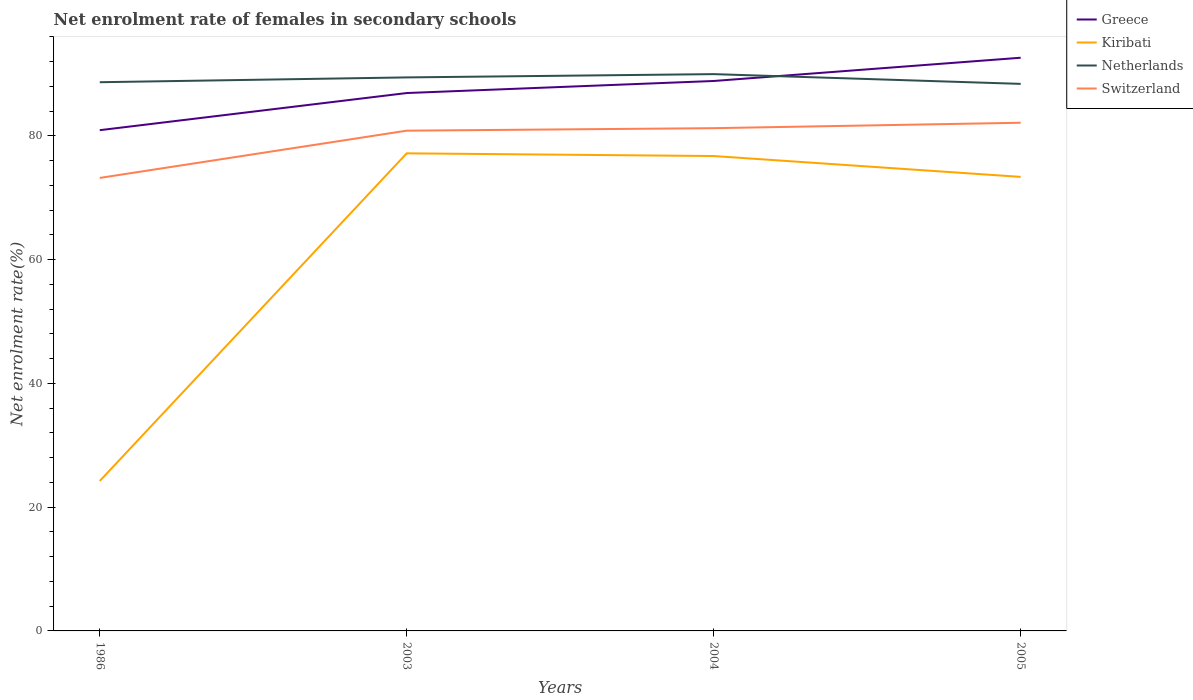How many different coloured lines are there?
Your answer should be compact. 4. Does the line corresponding to Switzerland intersect with the line corresponding to Kiribati?
Provide a short and direct response. No. Across all years, what is the maximum net enrolment rate of females in secondary schools in Greece?
Keep it short and to the point. 80.91. In which year was the net enrolment rate of females in secondary schools in Greece maximum?
Your response must be concise. 1986. What is the total net enrolment rate of females in secondary schools in Greece in the graph?
Give a very brief answer. -3.76. What is the difference between the highest and the second highest net enrolment rate of females in secondary schools in Greece?
Your answer should be very brief. 11.71. Is the net enrolment rate of females in secondary schools in Switzerland strictly greater than the net enrolment rate of females in secondary schools in Greece over the years?
Keep it short and to the point. Yes. How many lines are there?
Offer a terse response. 4. What is the difference between two consecutive major ticks on the Y-axis?
Your response must be concise. 20. Does the graph contain any zero values?
Ensure brevity in your answer.  No. Where does the legend appear in the graph?
Provide a short and direct response. Top right. How are the legend labels stacked?
Make the answer very short. Vertical. What is the title of the graph?
Provide a short and direct response. Net enrolment rate of females in secondary schools. What is the label or title of the X-axis?
Your answer should be compact. Years. What is the label or title of the Y-axis?
Give a very brief answer. Net enrolment rate(%). What is the Net enrolment rate(%) in Greece in 1986?
Your answer should be very brief. 80.91. What is the Net enrolment rate(%) in Kiribati in 1986?
Your response must be concise. 24.23. What is the Net enrolment rate(%) of Netherlands in 1986?
Your answer should be compact. 88.66. What is the Net enrolment rate(%) of Switzerland in 1986?
Ensure brevity in your answer.  73.2. What is the Net enrolment rate(%) in Greece in 2003?
Give a very brief answer. 86.91. What is the Net enrolment rate(%) in Kiribati in 2003?
Keep it short and to the point. 77.17. What is the Net enrolment rate(%) in Netherlands in 2003?
Your answer should be very brief. 89.44. What is the Net enrolment rate(%) of Switzerland in 2003?
Provide a short and direct response. 80.83. What is the Net enrolment rate(%) of Greece in 2004?
Your response must be concise. 88.86. What is the Net enrolment rate(%) of Kiribati in 2004?
Offer a terse response. 76.73. What is the Net enrolment rate(%) of Netherlands in 2004?
Your response must be concise. 89.97. What is the Net enrolment rate(%) in Switzerland in 2004?
Offer a terse response. 81.24. What is the Net enrolment rate(%) of Greece in 2005?
Give a very brief answer. 92.62. What is the Net enrolment rate(%) in Kiribati in 2005?
Your answer should be compact. 73.36. What is the Net enrolment rate(%) in Netherlands in 2005?
Your answer should be very brief. 88.39. What is the Net enrolment rate(%) in Switzerland in 2005?
Offer a terse response. 82.11. Across all years, what is the maximum Net enrolment rate(%) of Greece?
Provide a succinct answer. 92.62. Across all years, what is the maximum Net enrolment rate(%) in Kiribati?
Ensure brevity in your answer.  77.17. Across all years, what is the maximum Net enrolment rate(%) in Netherlands?
Offer a terse response. 89.97. Across all years, what is the maximum Net enrolment rate(%) in Switzerland?
Your answer should be compact. 82.11. Across all years, what is the minimum Net enrolment rate(%) in Greece?
Ensure brevity in your answer.  80.91. Across all years, what is the minimum Net enrolment rate(%) in Kiribati?
Make the answer very short. 24.23. Across all years, what is the minimum Net enrolment rate(%) in Netherlands?
Your response must be concise. 88.39. Across all years, what is the minimum Net enrolment rate(%) of Switzerland?
Ensure brevity in your answer.  73.2. What is the total Net enrolment rate(%) of Greece in the graph?
Ensure brevity in your answer.  349.3. What is the total Net enrolment rate(%) in Kiribati in the graph?
Make the answer very short. 251.49. What is the total Net enrolment rate(%) of Netherlands in the graph?
Provide a short and direct response. 356.46. What is the total Net enrolment rate(%) of Switzerland in the graph?
Provide a succinct answer. 317.37. What is the difference between the Net enrolment rate(%) in Greece in 1986 and that in 2003?
Ensure brevity in your answer.  -6. What is the difference between the Net enrolment rate(%) of Kiribati in 1986 and that in 2003?
Make the answer very short. -52.95. What is the difference between the Net enrolment rate(%) of Netherlands in 1986 and that in 2003?
Your answer should be very brief. -0.78. What is the difference between the Net enrolment rate(%) of Switzerland in 1986 and that in 2003?
Offer a very short reply. -7.63. What is the difference between the Net enrolment rate(%) in Greece in 1986 and that in 2004?
Your answer should be very brief. -7.95. What is the difference between the Net enrolment rate(%) in Kiribati in 1986 and that in 2004?
Keep it short and to the point. -52.51. What is the difference between the Net enrolment rate(%) of Netherlands in 1986 and that in 2004?
Offer a very short reply. -1.31. What is the difference between the Net enrolment rate(%) in Switzerland in 1986 and that in 2004?
Provide a short and direct response. -8.04. What is the difference between the Net enrolment rate(%) in Greece in 1986 and that in 2005?
Ensure brevity in your answer.  -11.71. What is the difference between the Net enrolment rate(%) of Kiribati in 1986 and that in 2005?
Provide a short and direct response. -49.14. What is the difference between the Net enrolment rate(%) in Netherlands in 1986 and that in 2005?
Offer a very short reply. 0.27. What is the difference between the Net enrolment rate(%) in Switzerland in 1986 and that in 2005?
Offer a terse response. -8.91. What is the difference between the Net enrolment rate(%) of Greece in 2003 and that in 2004?
Ensure brevity in your answer.  -1.95. What is the difference between the Net enrolment rate(%) in Kiribati in 2003 and that in 2004?
Your answer should be compact. 0.44. What is the difference between the Net enrolment rate(%) of Netherlands in 2003 and that in 2004?
Offer a terse response. -0.53. What is the difference between the Net enrolment rate(%) in Switzerland in 2003 and that in 2004?
Make the answer very short. -0.41. What is the difference between the Net enrolment rate(%) in Greece in 2003 and that in 2005?
Provide a succinct answer. -5.7. What is the difference between the Net enrolment rate(%) in Kiribati in 2003 and that in 2005?
Give a very brief answer. 3.81. What is the difference between the Net enrolment rate(%) of Netherlands in 2003 and that in 2005?
Give a very brief answer. 1.04. What is the difference between the Net enrolment rate(%) of Switzerland in 2003 and that in 2005?
Offer a terse response. -1.28. What is the difference between the Net enrolment rate(%) of Greece in 2004 and that in 2005?
Your answer should be very brief. -3.76. What is the difference between the Net enrolment rate(%) of Kiribati in 2004 and that in 2005?
Ensure brevity in your answer.  3.37. What is the difference between the Net enrolment rate(%) in Netherlands in 2004 and that in 2005?
Provide a short and direct response. 1.57. What is the difference between the Net enrolment rate(%) of Switzerland in 2004 and that in 2005?
Your answer should be compact. -0.87. What is the difference between the Net enrolment rate(%) of Greece in 1986 and the Net enrolment rate(%) of Kiribati in 2003?
Provide a short and direct response. 3.74. What is the difference between the Net enrolment rate(%) of Greece in 1986 and the Net enrolment rate(%) of Netherlands in 2003?
Give a very brief answer. -8.53. What is the difference between the Net enrolment rate(%) of Greece in 1986 and the Net enrolment rate(%) of Switzerland in 2003?
Provide a succinct answer. 0.08. What is the difference between the Net enrolment rate(%) of Kiribati in 1986 and the Net enrolment rate(%) of Netherlands in 2003?
Offer a very short reply. -65.21. What is the difference between the Net enrolment rate(%) in Kiribati in 1986 and the Net enrolment rate(%) in Switzerland in 2003?
Your answer should be very brief. -56.6. What is the difference between the Net enrolment rate(%) of Netherlands in 1986 and the Net enrolment rate(%) of Switzerland in 2003?
Your answer should be compact. 7.83. What is the difference between the Net enrolment rate(%) of Greece in 1986 and the Net enrolment rate(%) of Kiribati in 2004?
Make the answer very short. 4.18. What is the difference between the Net enrolment rate(%) of Greece in 1986 and the Net enrolment rate(%) of Netherlands in 2004?
Offer a terse response. -9.06. What is the difference between the Net enrolment rate(%) of Greece in 1986 and the Net enrolment rate(%) of Switzerland in 2004?
Your response must be concise. -0.33. What is the difference between the Net enrolment rate(%) of Kiribati in 1986 and the Net enrolment rate(%) of Netherlands in 2004?
Keep it short and to the point. -65.74. What is the difference between the Net enrolment rate(%) in Kiribati in 1986 and the Net enrolment rate(%) in Switzerland in 2004?
Provide a short and direct response. -57.01. What is the difference between the Net enrolment rate(%) of Netherlands in 1986 and the Net enrolment rate(%) of Switzerland in 2004?
Keep it short and to the point. 7.43. What is the difference between the Net enrolment rate(%) in Greece in 1986 and the Net enrolment rate(%) in Kiribati in 2005?
Offer a terse response. 7.55. What is the difference between the Net enrolment rate(%) of Greece in 1986 and the Net enrolment rate(%) of Netherlands in 2005?
Your answer should be compact. -7.48. What is the difference between the Net enrolment rate(%) in Greece in 1986 and the Net enrolment rate(%) in Switzerland in 2005?
Your answer should be compact. -1.2. What is the difference between the Net enrolment rate(%) of Kiribati in 1986 and the Net enrolment rate(%) of Netherlands in 2005?
Ensure brevity in your answer.  -64.17. What is the difference between the Net enrolment rate(%) in Kiribati in 1986 and the Net enrolment rate(%) in Switzerland in 2005?
Your response must be concise. -57.88. What is the difference between the Net enrolment rate(%) of Netherlands in 1986 and the Net enrolment rate(%) of Switzerland in 2005?
Offer a very short reply. 6.55. What is the difference between the Net enrolment rate(%) in Greece in 2003 and the Net enrolment rate(%) in Kiribati in 2004?
Your response must be concise. 10.18. What is the difference between the Net enrolment rate(%) in Greece in 2003 and the Net enrolment rate(%) in Netherlands in 2004?
Keep it short and to the point. -3.06. What is the difference between the Net enrolment rate(%) of Greece in 2003 and the Net enrolment rate(%) of Switzerland in 2004?
Offer a very short reply. 5.68. What is the difference between the Net enrolment rate(%) of Kiribati in 2003 and the Net enrolment rate(%) of Netherlands in 2004?
Provide a short and direct response. -12.8. What is the difference between the Net enrolment rate(%) in Kiribati in 2003 and the Net enrolment rate(%) in Switzerland in 2004?
Make the answer very short. -4.06. What is the difference between the Net enrolment rate(%) of Netherlands in 2003 and the Net enrolment rate(%) of Switzerland in 2004?
Provide a short and direct response. 8.2. What is the difference between the Net enrolment rate(%) of Greece in 2003 and the Net enrolment rate(%) of Kiribati in 2005?
Your answer should be compact. 13.55. What is the difference between the Net enrolment rate(%) of Greece in 2003 and the Net enrolment rate(%) of Netherlands in 2005?
Keep it short and to the point. -1.48. What is the difference between the Net enrolment rate(%) in Greece in 2003 and the Net enrolment rate(%) in Switzerland in 2005?
Your answer should be compact. 4.8. What is the difference between the Net enrolment rate(%) of Kiribati in 2003 and the Net enrolment rate(%) of Netherlands in 2005?
Provide a short and direct response. -11.22. What is the difference between the Net enrolment rate(%) of Kiribati in 2003 and the Net enrolment rate(%) of Switzerland in 2005?
Provide a succinct answer. -4.94. What is the difference between the Net enrolment rate(%) of Netherlands in 2003 and the Net enrolment rate(%) of Switzerland in 2005?
Offer a terse response. 7.33. What is the difference between the Net enrolment rate(%) in Greece in 2004 and the Net enrolment rate(%) in Kiribati in 2005?
Offer a terse response. 15.5. What is the difference between the Net enrolment rate(%) of Greece in 2004 and the Net enrolment rate(%) of Netherlands in 2005?
Ensure brevity in your answer.  0.47. What is the difference between the Net enrolment rate(%) in Greece in 2004 and the Net enrolment rate(%) in Switzerland in 2005?
Make the answer very short. 6.75. What is the difference between the Net enrolment rate(%) in Kiribati in 2004 and the Net enrolment rate(%) in Netherlands in 2005?
Provide a short and direct response. -11.66. What is the difference between the Net enrolment rate(%) of Kiribati in 2004 and the Net enrolment rate(%) of Switzerland in 2005?
Your answer should be compact. -5.38. What is the difference between the Net enrolment rate(%) of Netherlands in 2004 and the Net enrolment rate(%) of Switzerland in 2005?
Offer a very short reply. 7.86. What is the average Net enrolment rate(%) in Greece per year?
Keep it short and to the point. 87.32. What is the average Net enrolment rate(%) in Kiribati per year?
Keep it short and to the point. 62.87. What is the average Net enrolment rate(%) of Netherlands per year?
Make the answer very short. 89.11. What is the average Net enrolment rate(%) in Switzerland per year?
Your answer should be very brief. 79.34. In the year 1986, what is the difference between the Net enrolment rate(%) in Greece and Net enrolment rate(%) in Kiribati?
Provide a succinct answer. 56.68. In the year 1986, what is the difference between the Net enrolment rate(%) in Greece and Net enrolment rate(%) in Netherlands?
Your answer should be very brief. -7.75. In the year 1986, what is the difference between the Net enrolment rate(%) of Greece and Net enrolment rate(%) of Switzerland?
Offer a very short reply. 7.71. In the year 1986, what is the difference between the Net enrolment rate(%) in Kiribati and Net enrolment rate(%) in Netherlands?
Ensure brevity in your answer.  -64.44. In the year 1986, what is the difference between the Net enrolment rate(%) in Kiribati and Net enrolment rate(%) in Switzerland?
Make the answer very short. -48.97. In the year 1986, what is the difference between the Net enrolment rate(%) in Netherlands and Net enrolment rate(%) in Switzerland?
Provide a short and direct response. 15.46. In the year 2003, what is the difference between the Net enrolment rate(%) in Greece and Net enrolment rate(%) in Kiribati?
Provide a short and direct response. 9.74. In the year 2003, what is the difference between the Net enrolment rate(%) of Greece and Net enrolment rate(%) of Netherlands?
Keep it short and to the point. -2.53. In the year 2003, what is the difference between the Net enrolment rate(%) in Greece and Net enrolment rate(%) in Switzerland?
Offer a terse response. 6.08. In the year 2003, what is the difference between the Net enrolment rate(%) of Kiribati and Net enrolment rate(%) of Netherlands?
Your answer should be compact. -12.27. In the year 2003, what is the difference between the Net enrolment rate(%) in Kiribati and Net enrolment rate(%) in Switzerland?
Provide a succinct answer. -3.66. In the year 2003, what is the difference between the Net enrolment rate(%) of Netherlands and Net enrolment rate(%) of Switzerland?
Keep it short and to the point. 8.61. In the year 2004, what is the difference between the Net enrolment rate(%) of Greece and Net enrolment rate(%) of Kiribati?
Give a very brief answer. 12.13. In the year 2004, what is the difference between the Net enrolment rate(%) of Greece and Net enrolment rate(%) of Netherlands?
Provide a succinct answer. -1.11. In the year 2004, what is the difference between the Net enrolment rate(%) in Greece and Net enrolment rate(%) in Switzerland?
Ensure brevity in your answer.  7.62. In the year 2004, what is the difference between the Net enrolment rate(%) in Kiribati and Net enrolment rate(%) in Netherlands?
Offer a terse response. -13.23. In the year 2004, what is the difference between the Net enrolment rate(%) in Kiribati and Net enrolment rate(%) in Switzerland?
Make the answer very short. -4.5. In the year 2004, what is the difference between the Net enrolment rate(%) in Netherlands and Net enrolment rate(%) in Switzerland?
Offer a terse response. 8.73. In the year 2005, what is the difference between the Net enrolment rate(%) of Greece and Net enrolment rate(%) of Kiribati?
Keep it short and to the point. 19.25. In the year 2005, what is the difference between the Net enrolment rate(%) in Greece and Net enrolment rate(%) in Netherlands?
Keep it short and to the point. 4.22. In the year 2005, what is the difference between the Net enrolment rate(%) of Greece and Net enrolment rate(%) of Switzerland?
Offer a terse response. 10.51. In the year 2005, what is the difference between the Net enrolment rate(%) of Kiribati and Net enrolment rate(%) of Netherlands?
Keep it short and to the point. -15.03. In the year 2005, what is the difference between the Net enrolment rate(%) in Kiribati and Net enrolment rate(%) in Switzerland?
Keep it short and to the point. -8.75. In the year 2005, what is the difference between the Net enrolment rate(%) in Netherlands and Net enrolment rate(%) in Switzerland?
Your answer should be very brief. 6.28. What is the ratio of the Net enrolment rate(%) in Greece in 1986 to that in 2003?
Your response must be concise. 0.93. What is the ratio of the Net enrolment rate(%) in Kiribati in 1986 to that in 2003?
Make the answer very short. 0.31. What is the ratio of the Net enrolment rate(%) of Switzerland in 1986 to that in 2003?
Provide a succinct answer. 0.91. What is the ratio of the Net enrolment rate(%) in Greece in 1986 to that in 2004?
Ensure brevity in your answer.  0.91. What is the ratio of the Net enrolment rate(%) in Kiribati in 1986 to that in 2004?
Make the answer very short. 0.32. What is the ratio of the Net enrolment rate(%) in Netherlands in 1986 to that in 2004?
Provide a short and direct response. 0.99. What is the ratio of the Net enrolment rate(%) of Switzerland in 1986 to that in 2004?
Your answer should be very brief. 0.9. What is the ratio of the Net enrolment rate(%) in Greece in 1986 to that in 2005?
Your answer should be very brief. 0.87. What is the ratio of the Net enrolment rate(%) of Kiribati in 1986 to that in 2005?
Your response must be concise. 0.33. What is the ratio of the Net enrolment rate(%) of Switzerland in 1986 to that in 2005?
Ensure brevity in your answer.  0.89. What is the ratio of the Net enrolment rate(%) in Greece in 2003 to that in 2004?
Provide a short and direct response. 0.98. What is the ratio of the Net enrolment rate(%) in Greece in 2003 to that in 2005?
Your answer should be very brief. 0.94. What is the ratio of the Net enrolment rate(%) of Kiribati in 2003 to that in 2005?
Your answer should be very brief. 1.05. What is the ratio of the Net enrolment rate(%) of Netherlands in 2003 to that in 2005?
Your answer should be compact. 1.01. What is the ratio of the Net enrolment rate(%) of Switzerland in 2003 to that in 2005?
Offer a very short reply. 0.98. What is the ratio of the Net enrolment rate(%) in Greece in 2004 to that in 2005?
Provide a succinct answer. 0.96. What is the ratio of the Net enrolment rate(%) in Kiribati in 2004 to that in 2005?
Your response must be concise. 1.05. What is the ratio of the Net enrolment rate(%) of Netherlands in 2004 to that in 2005?
Your answer should be compact. 1.02. What is the ratio of the Net enrolment rate(%) in Switzerland in 2004 to that in 2005?
Your answer should be compact. 0.99. What is the difference between the highest and the second highest Net enrolment rate(%) in Greece?
Make the answer very short. 3.76. What is the difference between the highest and the second highest Net enrolment rate(%) in Kiribati?
Your response must be concise. 0.44. What is the difference between the highest and the second highest Net enrolment rate(%) of Netherlands?
Ensure brevity in your answer.  0.53. What is the difference between the highest and the second highest Net enrolment rate(%) of Switzerland?
Provide a short and direct response. 0.87. What is the difference between the highest and the lowest Net enrolment rate(%) of Greece?
Provide a succinct answer. 11.71. What is the difference between the highest and the lowest Net enrolment rate(%) in Kiribati?
Provide a short and direct response. 52.95. What is the difference between the highest and the lowest Net enrolment rate(%) in Netherlands?
Give a very brief answer. 1.57. What is the difference between the highest and the lowest Net enrolment rate(%) of Switzerland?
Provide a short and direct response. 8.91. 